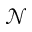<formula> <loc_0><loc_0><loc_500><loc_500>\mathcal { N }</formula> 